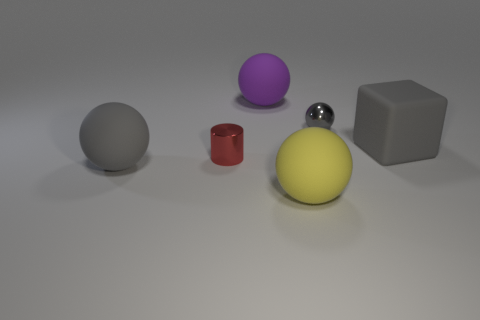Add 2 large gray matte objects. How many objects exist? 8 Subtract all cylinders. How many objects are left? 5 Add 4 small red shiny cylinders. How many small red shiny cylinders are left? 5 Add 6 metal balls. How many metal balls exist? 7 Subtract 0 cyan balls. How many objects are left? 6 Subtract all large brown matte spheres. Subtract all big purple objects. How many objects are left? 5 